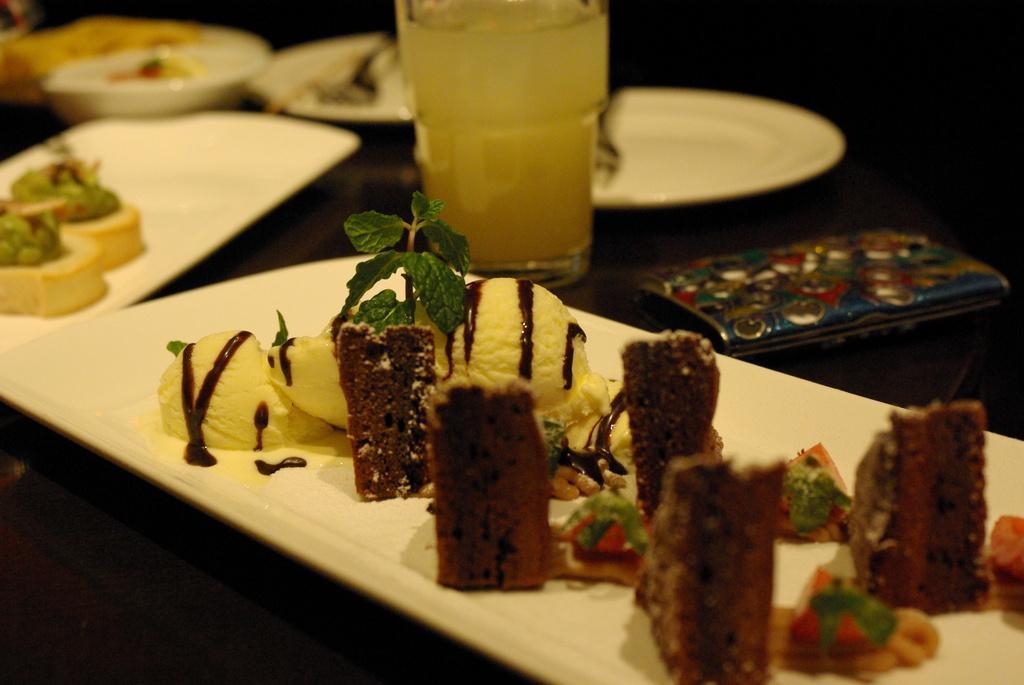Can you describe this image briefly? In this picture we can see some places, there is some food present in these plates, we can see a glass of drink in the middle, on the right side there is a wallet. 